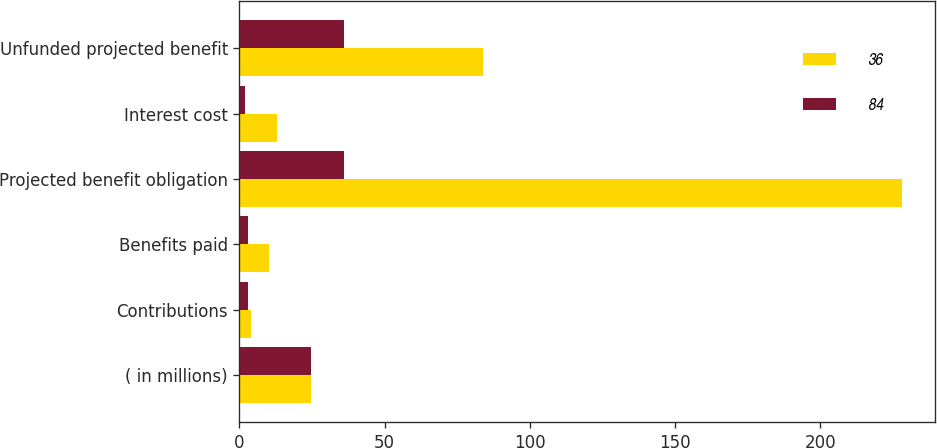<chart> <loc_0><loc_0><loc_500><loc_500><stacked_bar_chart><ecel><fcel>( in millions)<fcel>Contributions<fcel>Benefits paid<fcel>Projected benefit obligation<fcel>Interest cost<fcel>Unfunded projected benefit<nl><fcel>36<fcel>24.5<fcel>4<fcel>10<fcel>228<fcel>13<fcel>84<nl><fcel>84<fcel>24.5<fcel>3<fcel>3<fcel>36<fcel>2<fcel>36<nl></chart> 